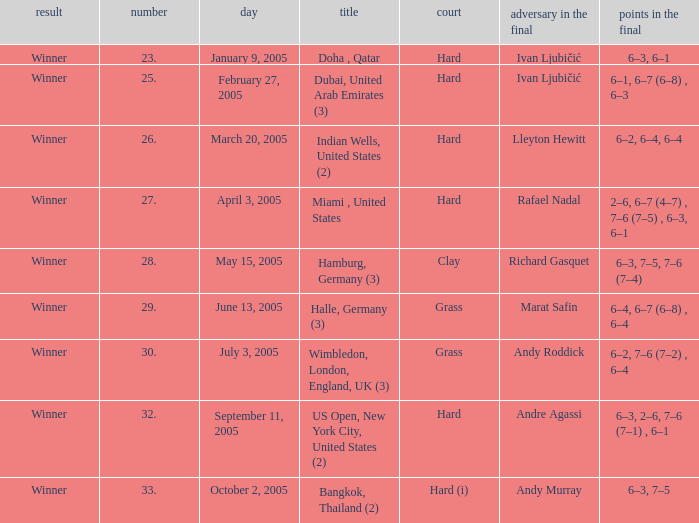In the championship Miami , United States, what is the score in the final? 2–6, 6–7 (4–7) , 7–6 (7–5) , 6–3, 6–1. 